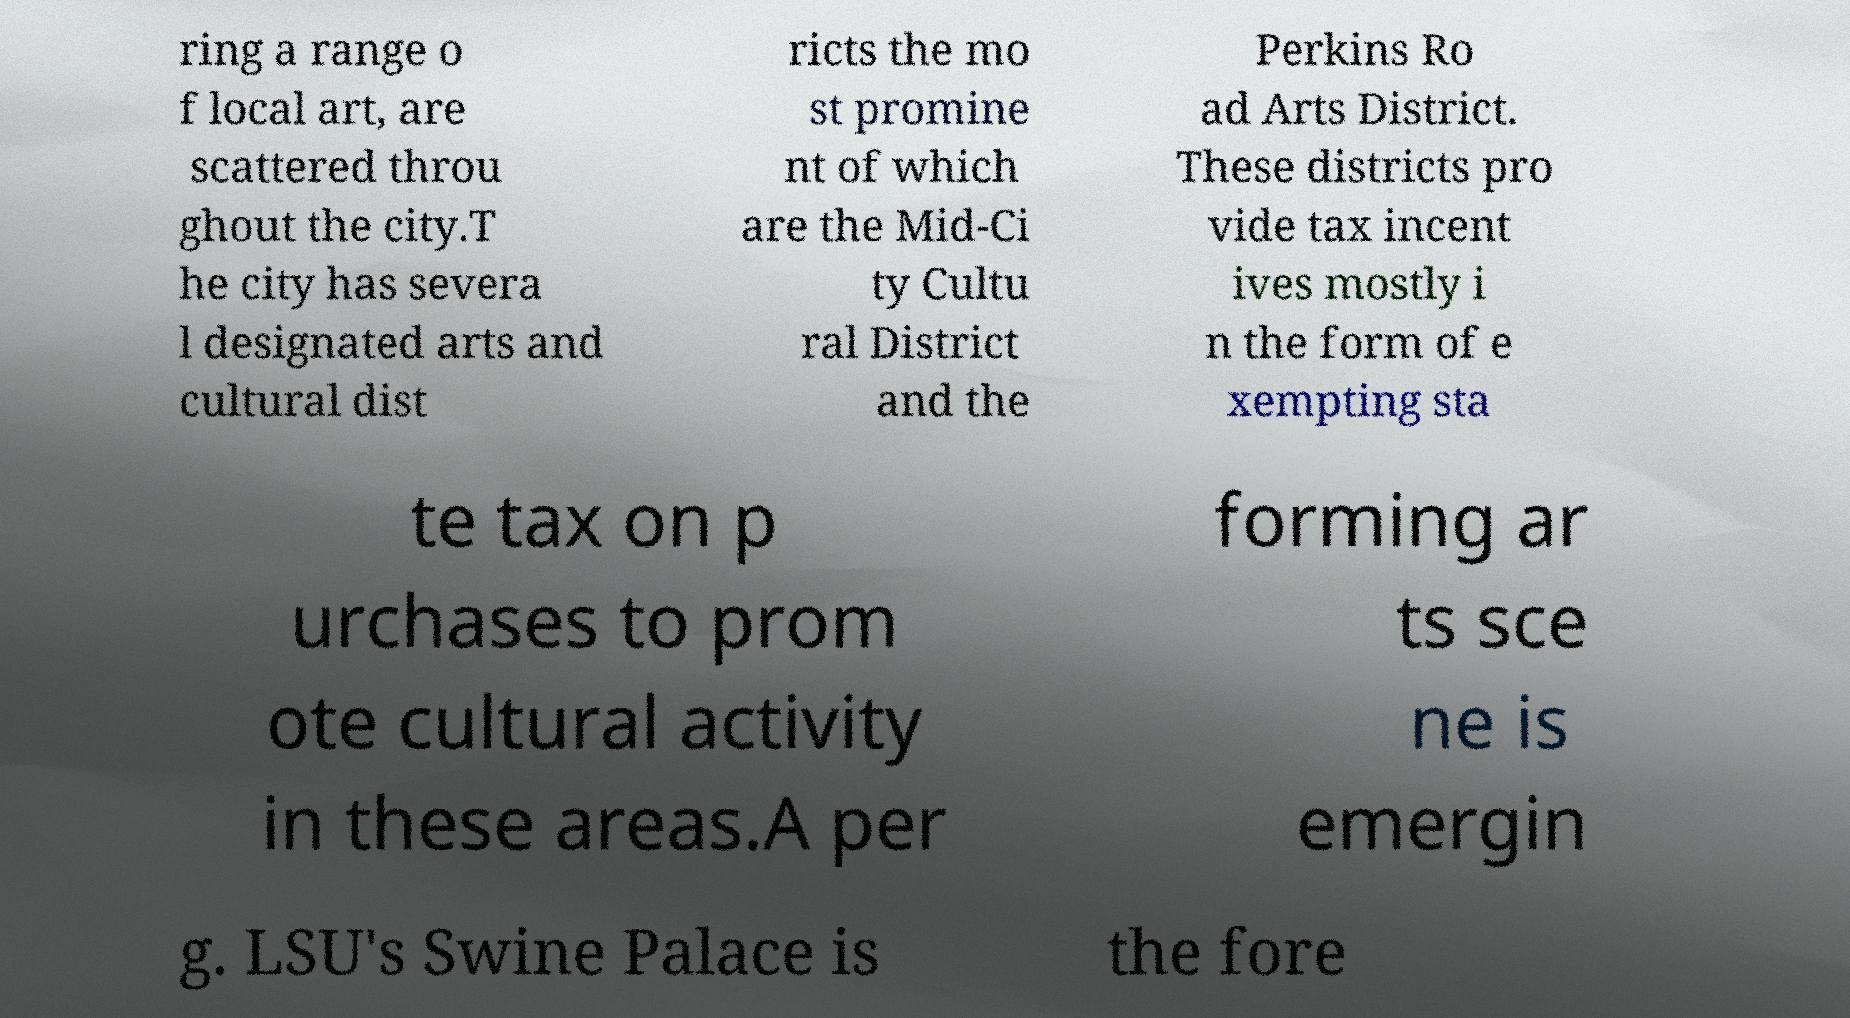I need the written content from this picture converted into text. Can you do that? ring a range o f local art, are scattered throu ghout the city.T he city has severa l designated arts and cultural dist ricts the mo st promine nt of which are the Mid-Ci ty Cultu ral District and the Perkins Ro ad Arts District. These districts pro vide tax incent ives mostly i n the form of e xempting sta te tax on p urchases to prom ote cultural activity in these areas.A per forming ar ts sce ne is emergin g. LSU's Swine Palace is the fore 